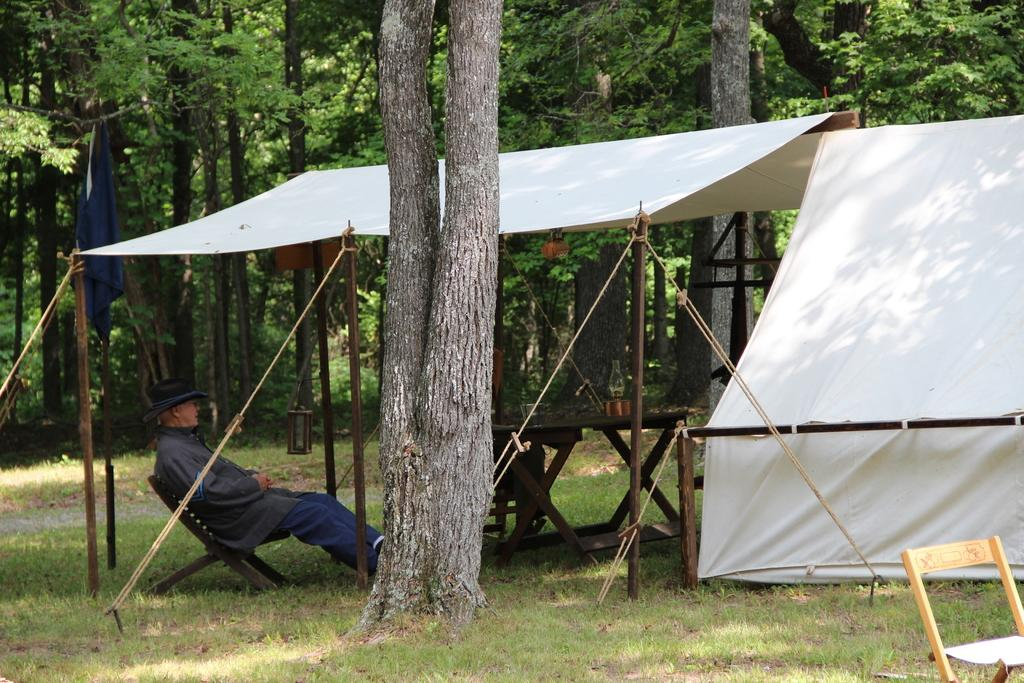What is the person in the image doing? The person is sitting on a chair in the image. What is located near the person? There is a table in the image. What type of shelter is visible in the image? There is a tent in the image. What is attached to the flag post? There is a flag in the image. What is the flag post is made of? There is a flag post in the image. What type of vegetation is visible in the image? There are trees in the image. What is visible beneath the person and the table? The ground is visible in the image. What type of stomach ache is the person experiencing in the image? There is no indication of a stomach ache or any discomfort in the image. 